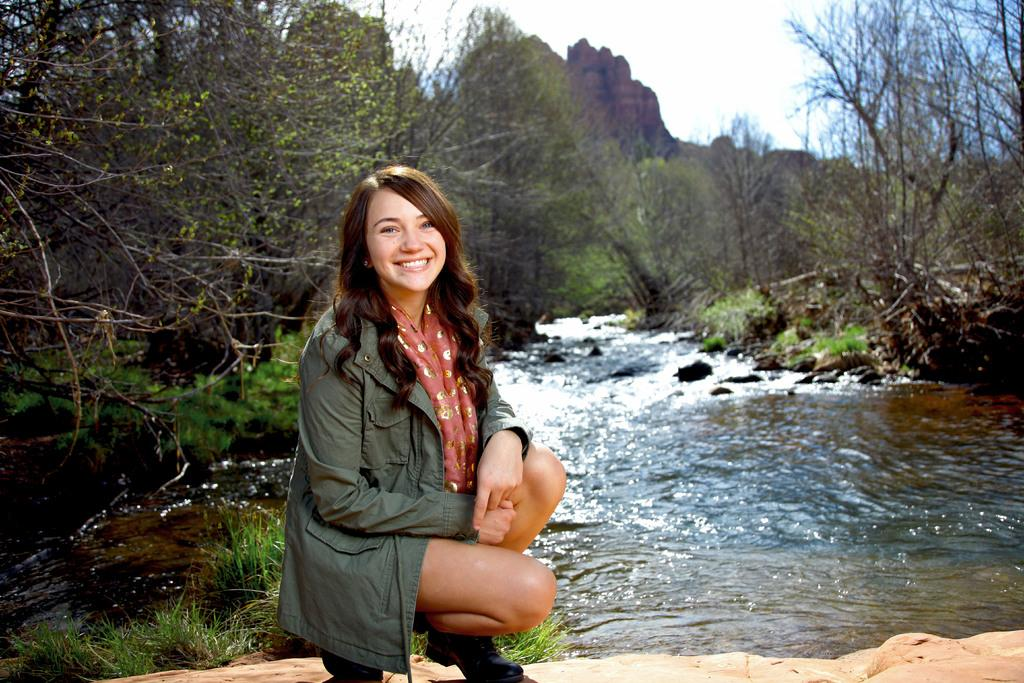Who is present in the image? There is a woman in the image. What is the woman doing in the image? The woman is smiling in the image. What is the woman wearing in the image? The woman is wearing a coat in the image. What can be seen in the background of the image? There is water flowing, trees, a hill, and a cloudy sky in the image. What type of meal is being prepared by the woman in the image? There is no indication in the image that the woman is preparing a meal, as she is simply smiling and wearing a coat. 